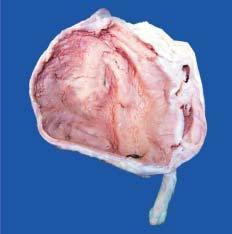what shows markedly dilated pelvis and calyces having irregular and ragged inner surface and containing necrotic debris and pus?
Answer the question using a single word or phrase. Sectioned surface 